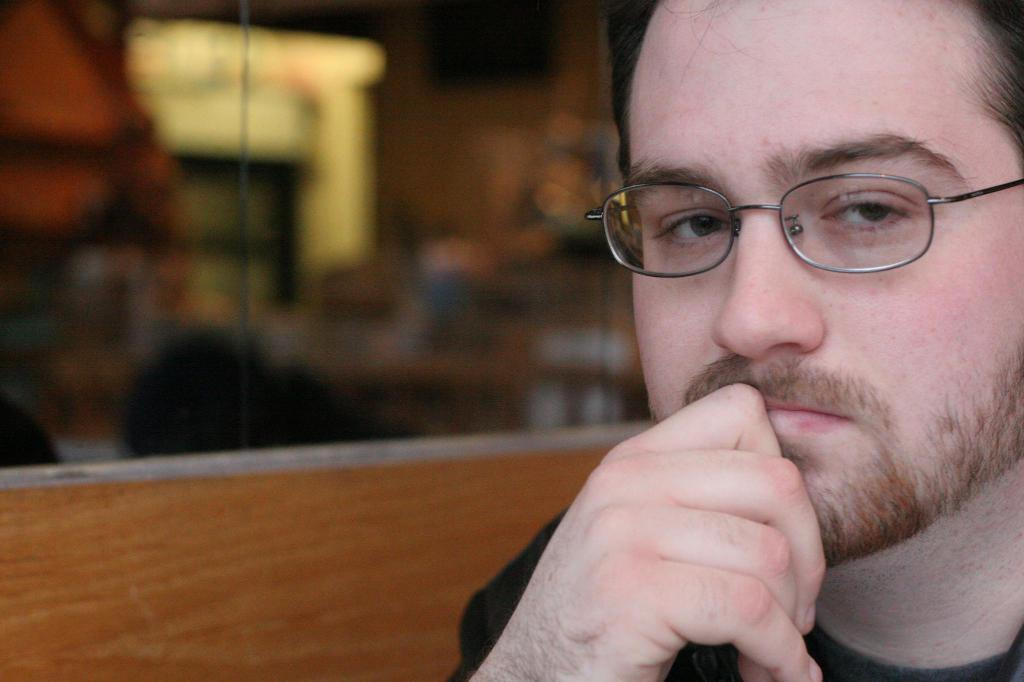Who is present in the image? There is a man in the image. What can be observed about the man's appearance? The man is wearing spectacles. What type of structure is visible in the image? The image appears to depict a glass door. What type of brass instrument is the man playing in the image? There is no brass instrument present in the image; the man is simply standing near a glass door. What kind of haircut does the man have in the image? The provided facts do not mention the man's haircut, so it cannot be determined from the image. 